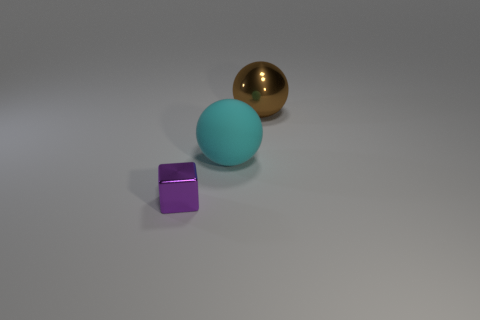How many large objects are purple cylinders or balls?
Your answer should be compact. 2. What number of objects are spheres behind the large cyan matte object or metallic things behind the tiny purple cube?
Give a very brief answer. 1. Are there fewer cyan objects than large gray matte objects?
Offer a very short reply. No. What number of other things are the same color as the big shiny object?
Provide a short and direct response. 0. How many big cyan objects are there?
Your answer should be very brief. 1. What number of objects are both right of the purple cube and in front of the large brown metallic object?
Make the answer very short. 1. What is the small purple object made of?
Offer a terse response. Metal. Is there a small blue rubber thing?
Keep it short and to the point. No. The thing that is in front of the rubber sphere is what color?
Keep it short and to the point. Purple. How many brown things are to the right of the big sphere that is left of the shiny object right of the purple cube?
Keep it short and to the point. 1. 